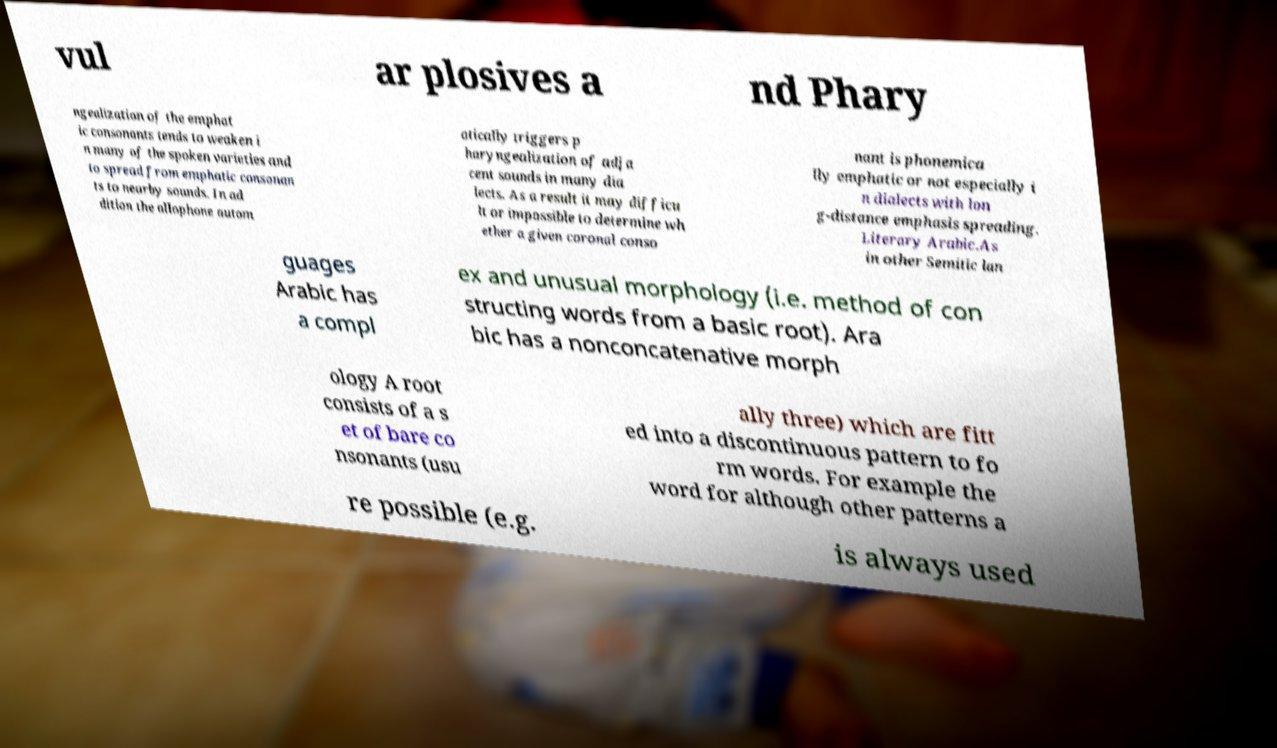Can you accurately transcribe the text from the provided image for me? vul ar plosives a nd Phary ngealization of the emphat ic consonants tends to weaken i n many of the spoken varieties and to spread from emphatic consonan ts to nearby sounds. In ad dition the allophone autom atically triggers p haryngealization of adja cent sounds in many dia lects. As a result it may difficu lt or impossible to determine wh ether a given coronal conso nant is phonemica lly emphatic or not especially i n dialects with lon g-distance emphasis spreading. Literary Arabic.As in other Semitic lan guages Arabic has a compl ex and unusual morphology (i.e. method of con structing words from a basic root). Ara bic has a nonconcatenative morph ology A root consists of a s et of bare co nsonants (usu ally three) which are fitt ed into a discontinuous pattern to fo rm words. For example the word for although other patterns a re possible (e.g. is always used 